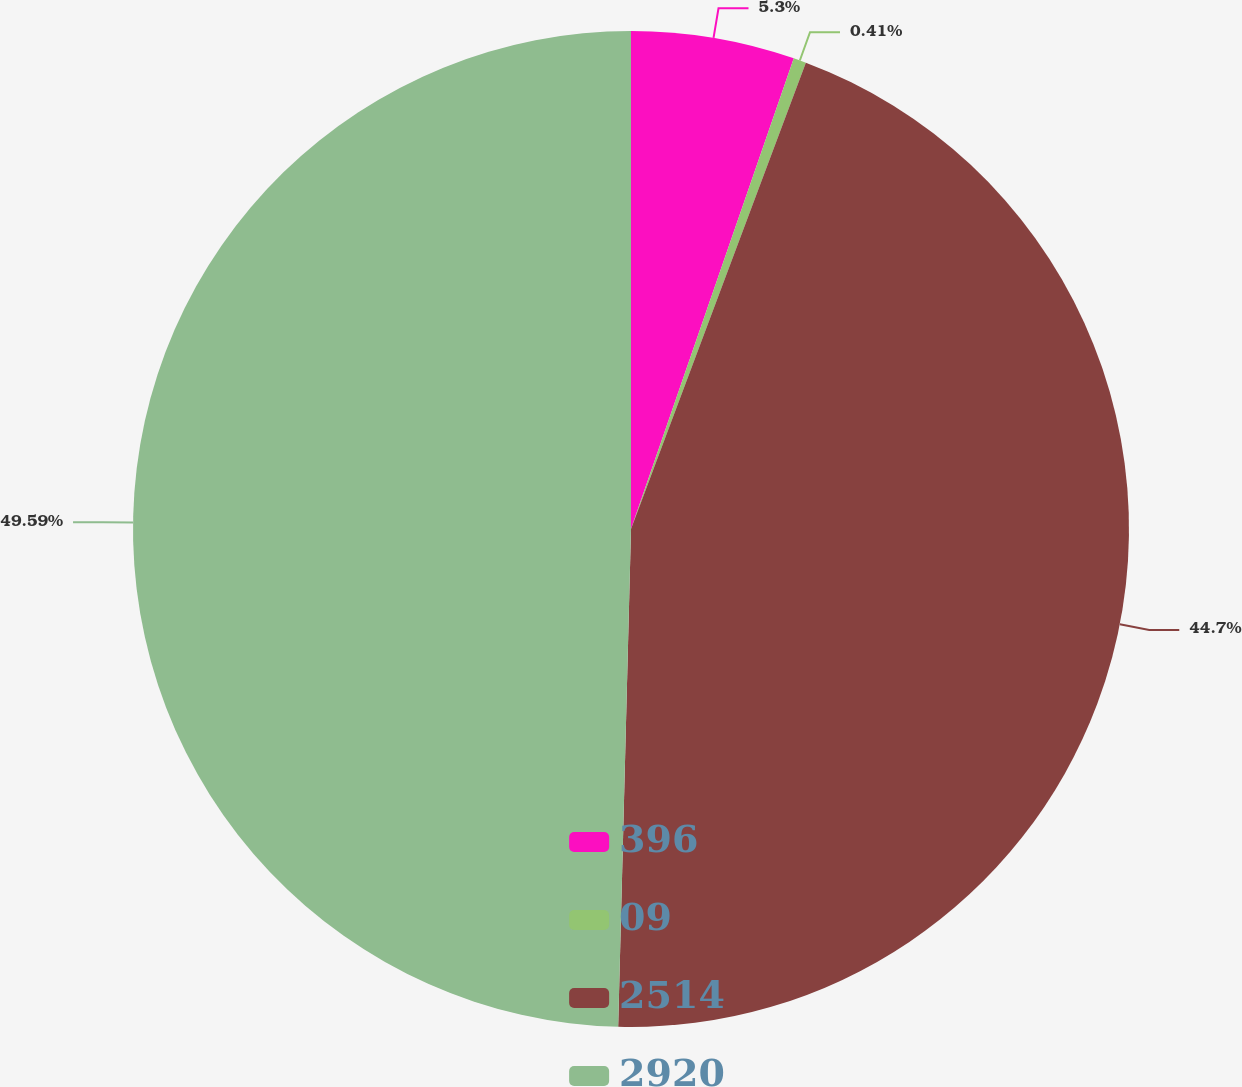Convert chart. <chart><loc_0><loc_0><loc_500><loc_500><pie_chart><fcel>396<fcel>09<fcel>2514<fcel>2920<nl><fcel>5.3%<fcel>0.41%<fcel>44.7%<fcel>49.59%<nl></chart> 